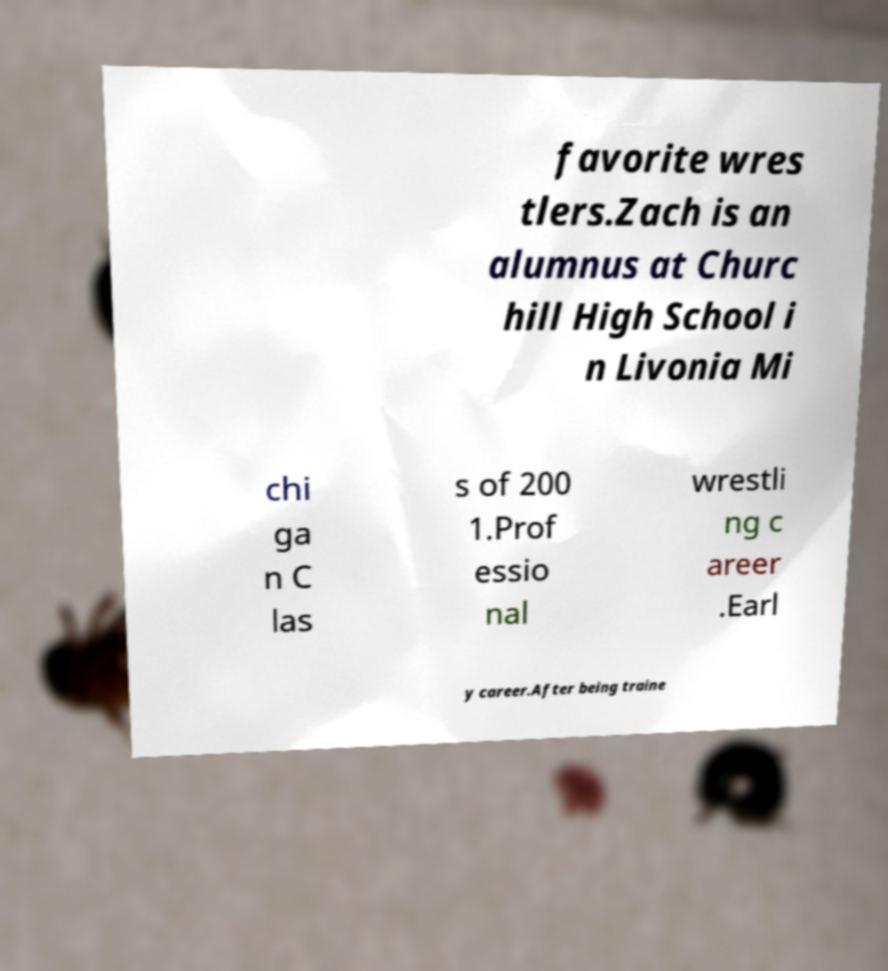There's text embedded in this image that I need extracted. Can you transcribe it verbatim? favorite wres tlers.Zach is an alumnus at Churc hill High School i n Livonia Mi chi ga n C las s of 200 1.Prof essio nal wrestli ng c areer .Earl y career.After being traine 